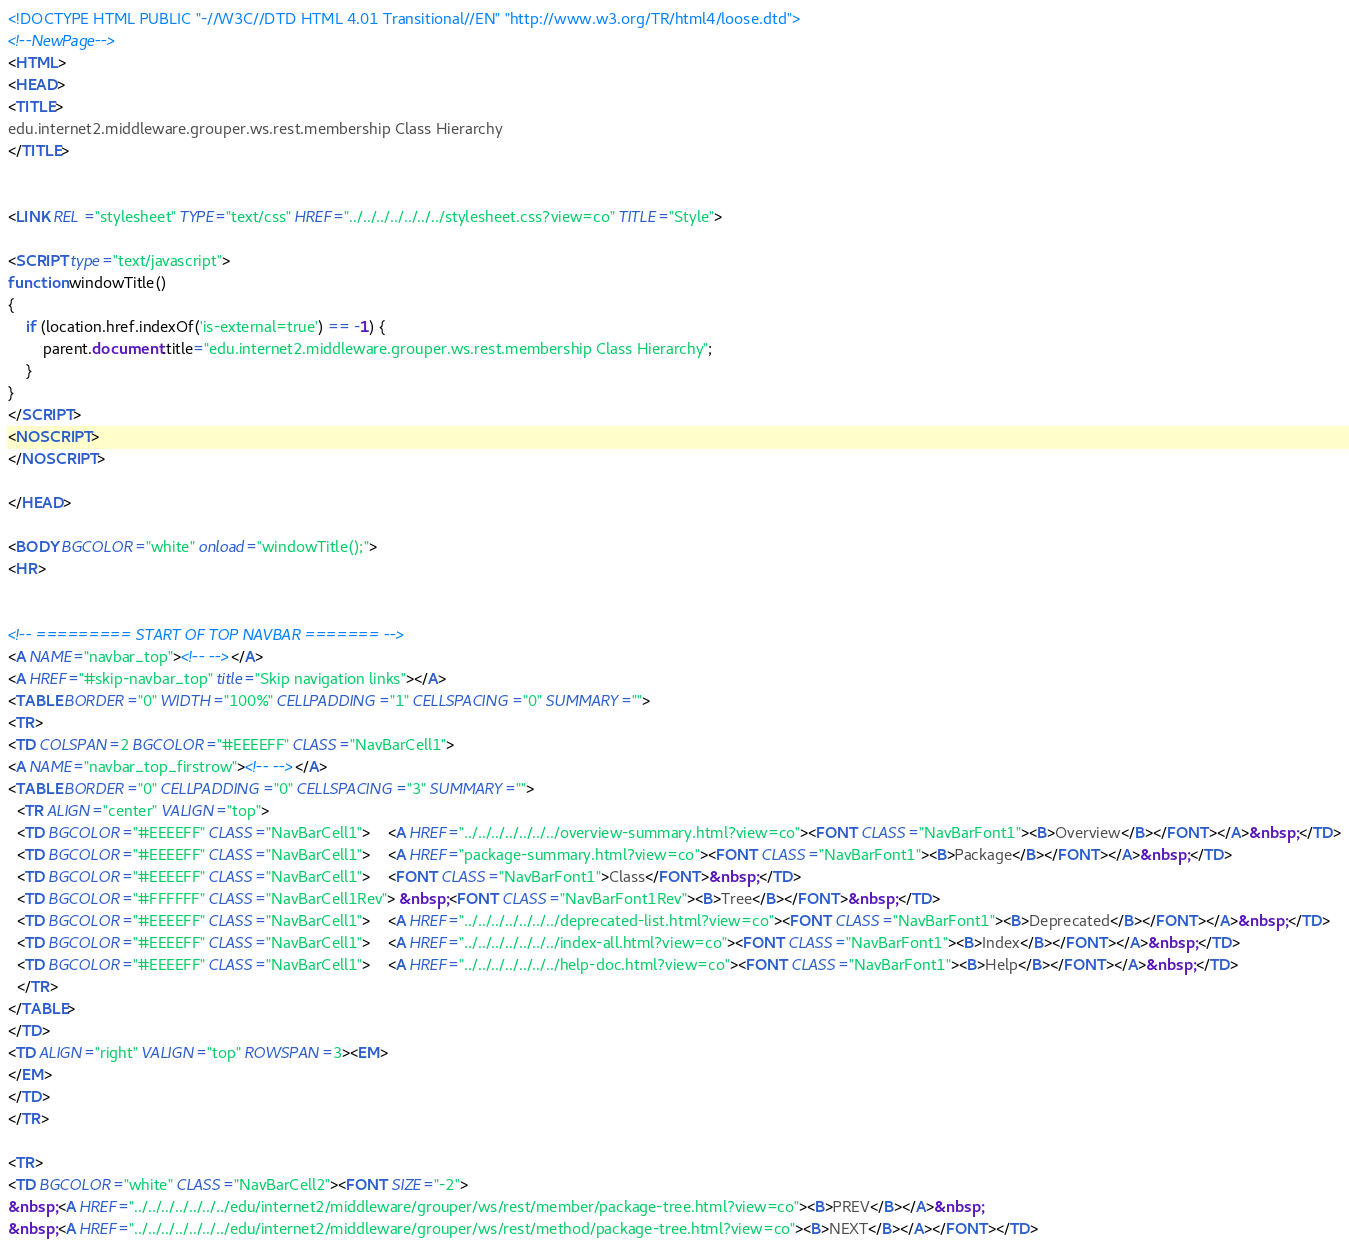Convert code to text. <code><loc_0><loc_0><loc_500><loc_500><_HTML_><!DOCTYPE HTML PUBLIC "-//W3C//DTD HTML 4.01 Transitional//EN" "http://www.w3.org/TR/html4/loose.dtd">
<!--NewPage-->
<HTML>
<HEAD>
<TITLE>
edu.internet2.middleware.grouper.ws.rest.membership Class Hierarchy
</TITLE>


<LINK REL ="stylesheet" TYPE="text/css" HREF="../../../../../../../stylesheet.css?view=co" TITLE="Style">

<SCRIPT type="text/javascript">
function windowTitle()
{
    if (location.href.indexOf('is-external=true') == -1) {
        parent.document.title="edu.internet2.middleware.grouper.ws.rest.membership Class Hierarchy";
    }
}
</SCRIPT>
<NOSCRIPT>
</NOSCRIPT>

</HEAD>

<BODY BGCOLOR="white" onload="windowTitle();">
<HR>


<!-- ========= START OF TOP NAVBAR ======= -->
<A NAME="navbar_top"><!-- --></A>
<A HREF="#skip-navbar_top" title="Skip navigation links"></A>
<TABLE BORDER="0" WIDTH="100%" CELLPADDING="1" CELLSPACING="0" SUMMARY="">
<TR>
<TD COLSPAN=2 BGCOLOR="#EEEEFF" CLASS="NavBarCell1">
<A NAME="navbar_top_firstrow"><!-- --></A>
<TABLE BORDER="0" CELLPADDING="0" CELLSPACING="3" SUMMARY="">
  <TR ALIGN="center" VALIGN="top">
  <TD BGCOLOR="#EEEEFF" CLASS="NavBarCell1">    <A HREF="../../../../../../../overview-summary.html?view=co"><FONT CLASS="NavBarFont1"><B>Overview</B></FONT></A>&nbsp;</TD>
  <TD BGCOLOR="#EEEEFF" CLASS="NavBarCell1">    <A HREF="package-summary.html?view=co"><FONT CLASS="NavBarFont1"><B>Package</B></FONT></A>&nbsp;</TD>
  <TD BGCOLOR="#EEEEFF" CLASS="NavBarCell1">    <FONT CLASS="NavBarFont1">Class</FONT>&nbsp;</TD>
  <TD BGCOLOR="#FFFFFF" CLASS="NavBarCell1Rev"> &nbsp;<FONT CLASS="NavBarFont1Rev"><B>Tree</B></FONT>&nbsp;</TD>
  <TD BGCOLOR="#EEEEFF" CLASS="NavBarCell1">    <A HREF="../../../../../../../deprecated-list.html?view=co"><FONT CLASS="NavBarFont1"><B>Deprecated</B></FONT></A>&nbsp;</TD>
  <TD BGCOLOR="#EEEEFF" CLASS="NavBarCell1">    <A HREF="../../../../../../../index-all.html?view=co"><FONT CLASS="NavBarFont1"><B>Index</B></FONT></A>&nbsp;</TD>
  <TD BGCOLOR="#EEEEFF" CLASS="NavBarCell1">    <A HREF="../../../../../../../help-doc.html?view=co"><FONT CLASS="NavBarFont1"><B>Help</B></FONT></A>&nbsp;</TD>
  </TR>
</TABLE>
</TD>
<TD ALIGN="right" VALIGN="top" ROWSPAN=3><EM>
</EM>
</TD>
</TR>

<TR>
<TD BGCOLOR="white" CLASS="NavBarCell2"><FONT SIZE="-2">
&nbsp;<A HREF="../../../../../../../edu/internet2/middleware/grouper/ws/rest/member/package-tree.html?view=co"><B>PREV</B></A>&nbsp;
&nbsp;<A HREF="../../../../../../../edu/internet2/middleware/grouper/ws/rest/method/package-tree.html?view=co"><B>NEXT</B></A></FONT></TD></code> 